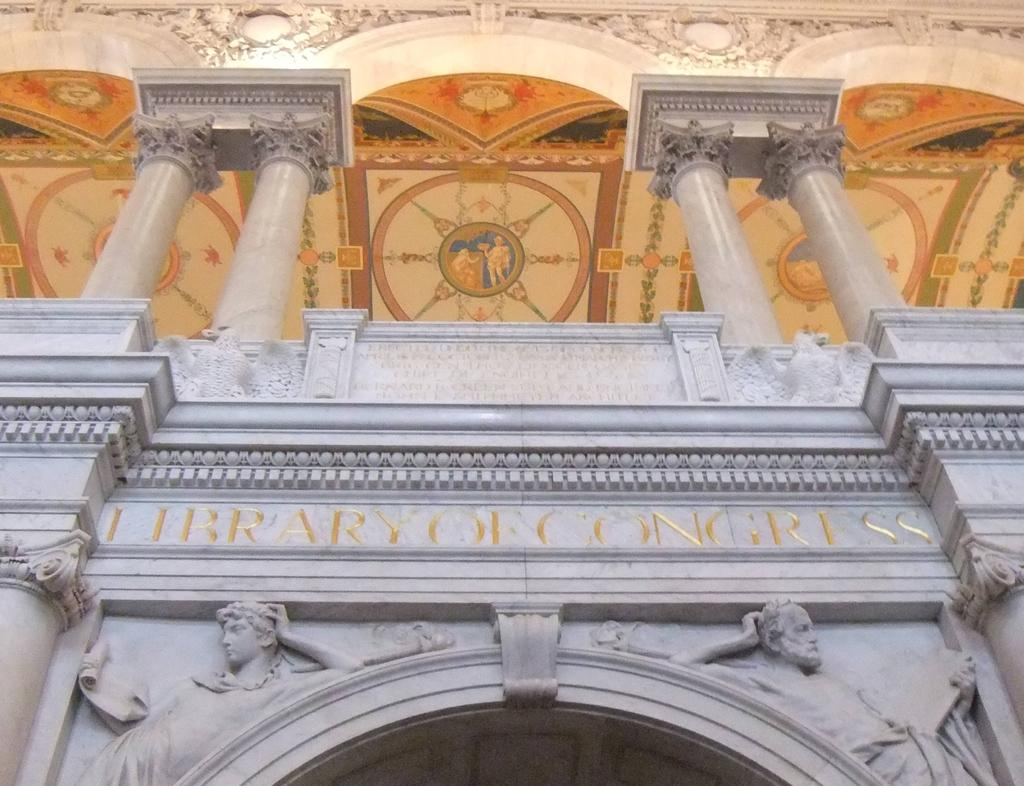What is the main structure in the center of the image? There is a library of congress in the center of the image. What architectural features can be seen at the top side of the image? There are pillars at the top side of the image. What architectural feature can be seen at the bottom side of the image? There is an arch at the bottom side of the image. Is there a spy hiding behind the pillars in the image? There is no indication of a spy or any hidden figures in the image; it only shows the library of congress, pillars, and an arch. 